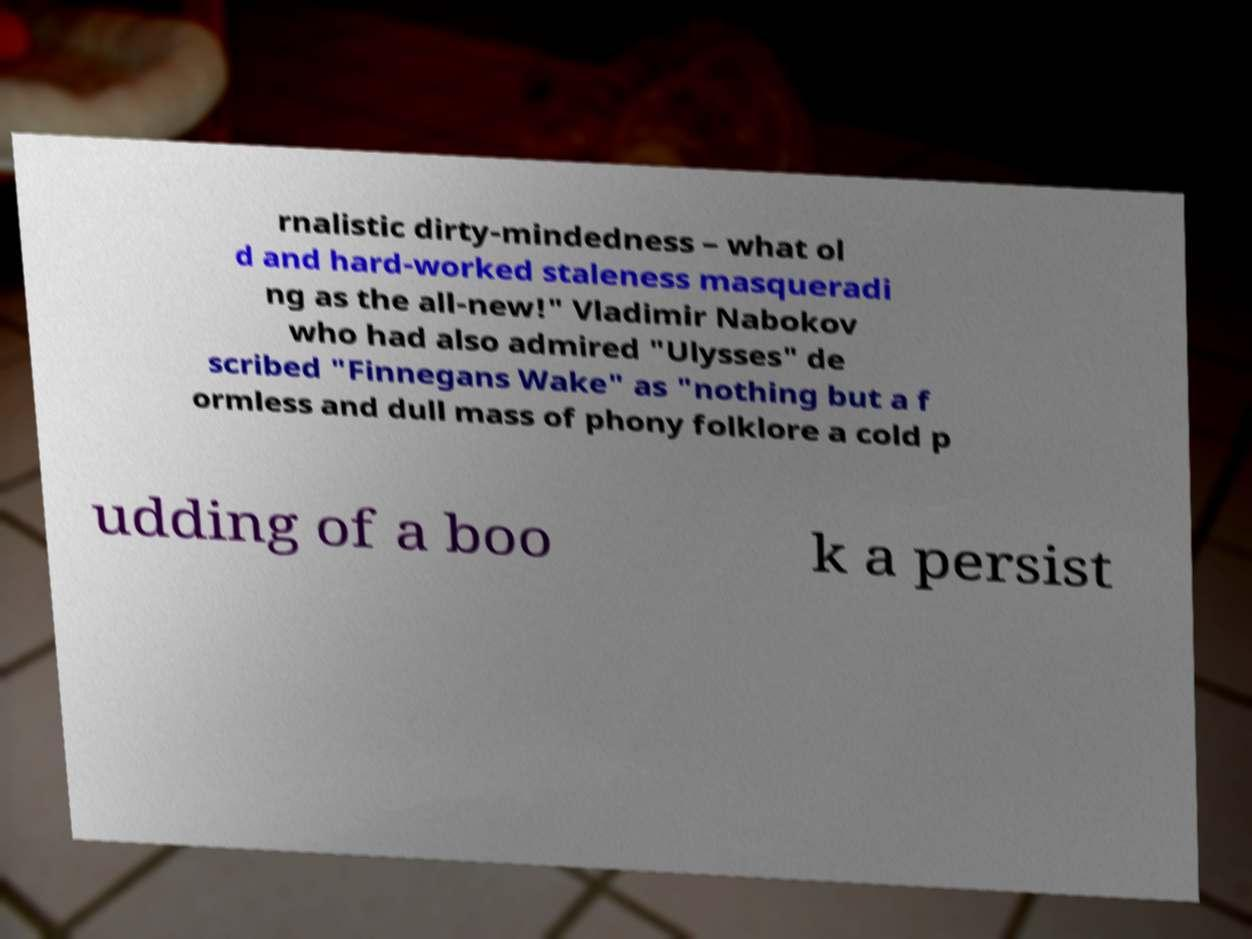What messages or text are displayed in this image? I need them in a readable, typed format. rnalistic dirty-mindedness – what ol d and hard-worked staleness masqueradi ng as the all-new!" Vladimir Nabokov who had also admired "Ulysses" de scribed "Finnegans Wake" as "nothing but a f ormless and dull mass of phony folklore a cold p udding of a boo k a persist 